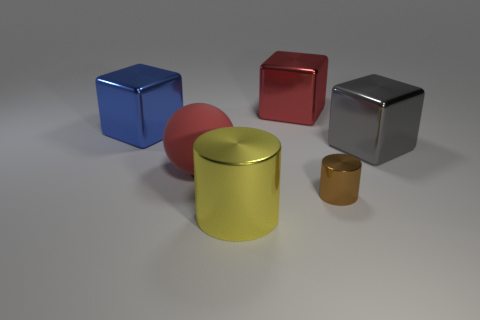There is a large red object that is in front of the red thing behind the blue shiny cube; what shape is it?
Provide a succinct answer. Sphere. Are there fewer big shiny cubes to the left of the big yellow metal object than metallic blocks on the left side of the big blue thing?
Keep it short and to the point. No. There is a blue metallic thing that is the same shape as the gray thing; what size is it?
Your answer should be very brief. Large. Are there any other things that are the same size as the red metallic object?
Offer a terse response. Yes. How many objects are large objects that are in front of the large gray shiny cube or red objects that are behind the big blue metal object?
Give a very brief answer. 3. Does the yellow cylinder have the same size as the brown metal cylinder?
Give a very brief answer. No. Is the number of brown shiny objects greater than the number of large purple metallic balls?
Your answer should be compact. Yes. What number of other things are there of the same color as the rubber ball?
Keep it short and to the point. 1. What number of things are large yellow metallic things or metallic cylinders?
Your answer should be very brief. 2. There is a big metal object that is in front of the gray object; does it have the same shape as the red matte object?
Your answer should be compact. No. 